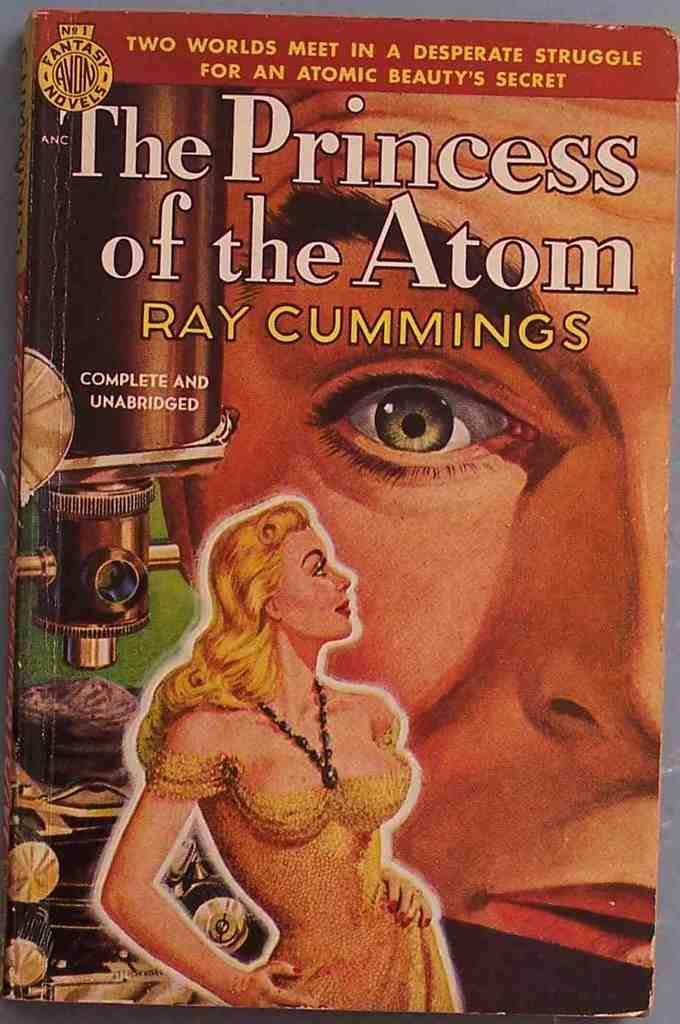<image>
Give a short and clear explanation of the subsequent image. A book by Ray Cummings has a woman on the front. 